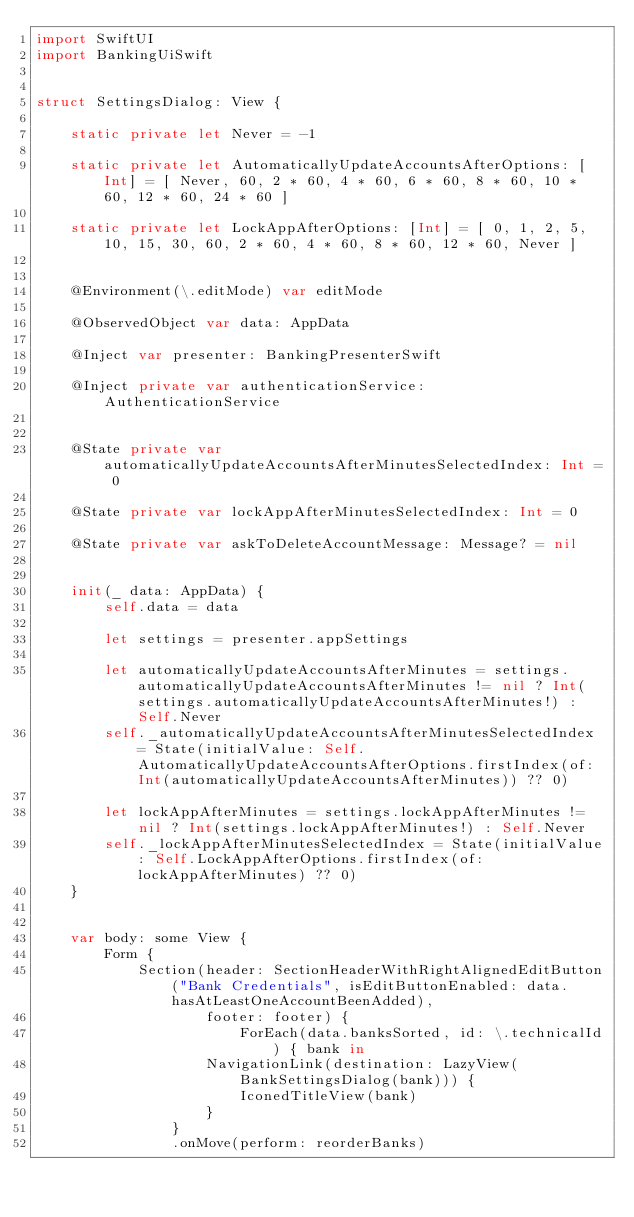<code> <loc_0><loc_0><loc_500><loc_500><_Swift_>import SwiftUI
import BankingUiSwift


struct SettingsDialog: View {
    
    static private let Never = -1
    
    static private let AutomaticallyUpdateAccountsAfterOptions: [Int] = [ Never, 60, 2 * 60, 4 * 60, 6 * 60, 8 * 60, 10 * 60, 12 * 60, 24 * 60 ]
    
    static private let LockAppAfterOptions: [Int] = [ 0, 1, 2, 5, 10, 15, 30, 60, 2 * 60, 4 * 60, 8 * 60, 12 * 60, Never ]
    
    
    @Environment(\.editMode) var editMode

    @ObservedObject var data: AppData

    @Inject var presenter: BankingPresenterSwift
    
    @Inject private var authenticationService: AuthenticationService

    
    @State private var automaticallyUpdateAccountsAfterMinutesSelectedIndex: Int = 0
    
    @State private var lockAppAfterMinutesSelectedIndex: Int = 0

    @State private var askToDeleteAccountMessage: Message? = nil
    
    
    init(_ data: AppData) {
        self.data = data
        
        let settings = presenter.appSettings
        
        let automaticallyUpdateAccountsAfterMinutes = settings.automaticallyUpdateAccountsAfterMinutes != nil ? Int(settings.automaticallyUpdateAccountsAfterMinutes!) : Self.Never
        self._automaticallyUpdateAccountsAfterMinutesSelectedIndex = State(initialValue: Self.AutomaticallyUpdateAccountsAfterOptions.firstIndex(of: Int(automaticallyUpdateAccountsAfterMinutes)) ?? 0)
        
        let lockAppAfterMinutes = settings.lockAppAfterMinutes != nil ? Int(settings.lockAppAfterMinutes!) : Self.Never
        self._lockAppAfterMinutesSelectedIndex = State(initialValue: Self.LockAppAfterOptions.firstIndex(of: lockAppAfterMinutes) ?? 0)
    }


    var body: some View {
        Form {
            Section(header: SectionHeaderWithRightAlignedEditButton("Bank Credentials", isEditButtonEnabled: data.hasAtLeastOneAccountBeenAdded),
                    footer: footer) {
                        ForEach(data.banksSorted, id: \.technicalId) { bank in
                    NavigationLink(destination: LazyView(BankSettingsDialog(bank))) {
                        IconedTitleView(bank)
                    }
                }
                .onMove(perform: reorderBanks)</code> 